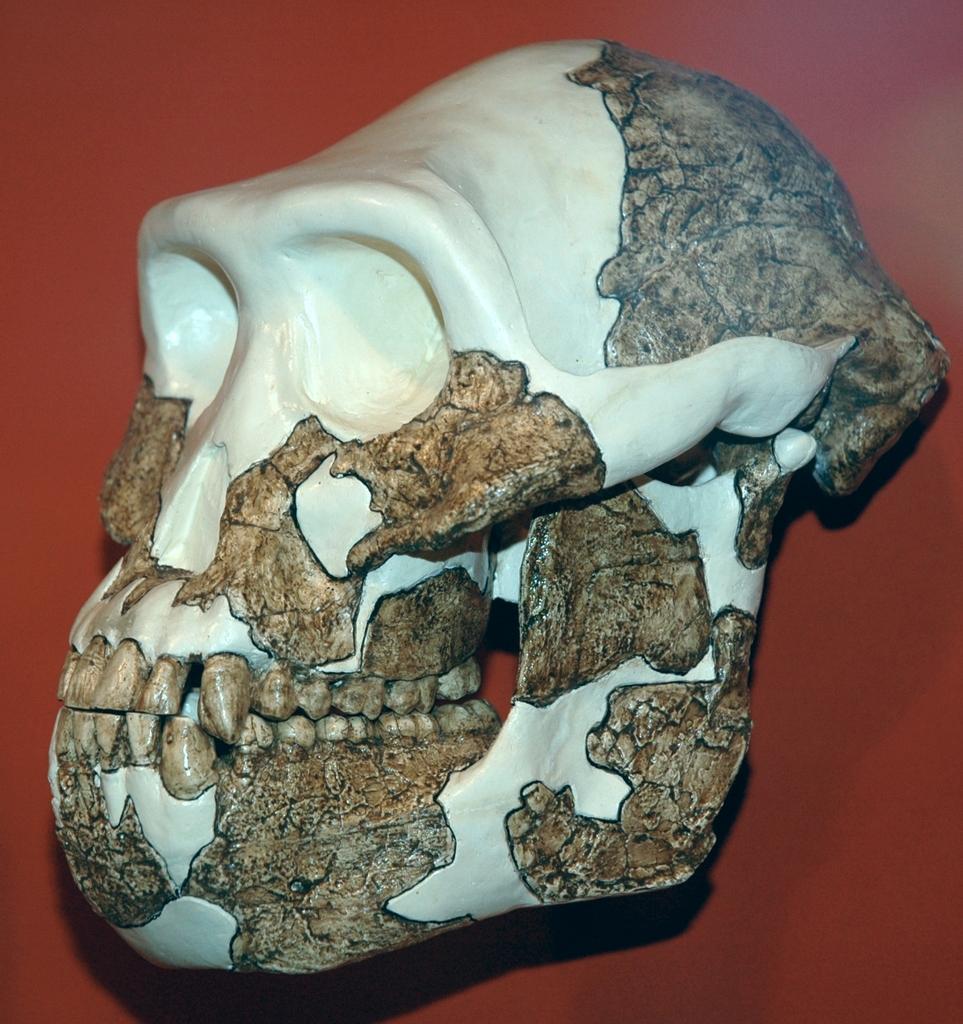Please provide a concise description of this image. In this image we can see a skull, here is the teeth. 